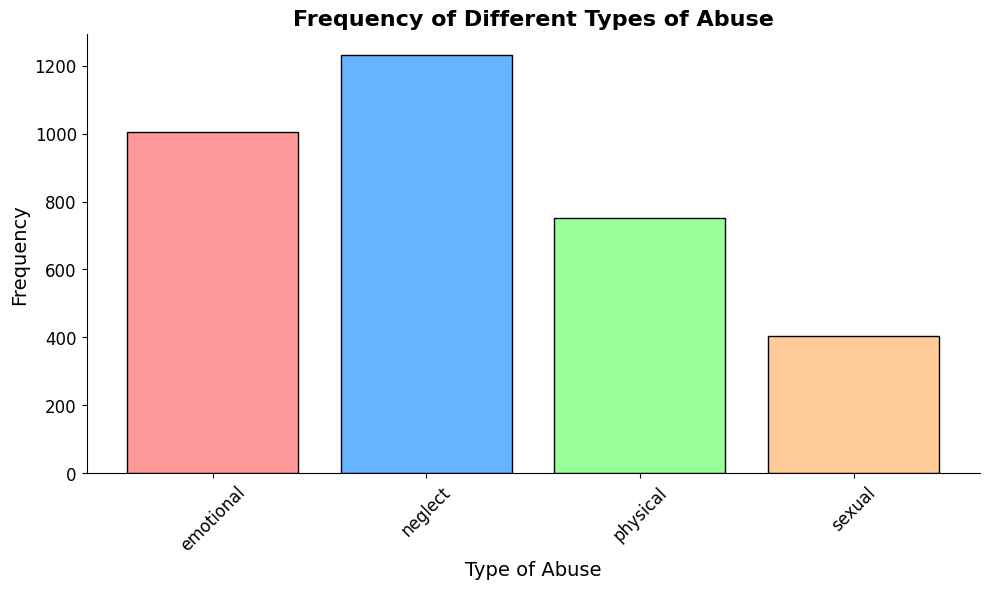Which type of abuse has the highest frequency? By observing the heights of the bars, which represent the frequencies, we can see that the bar for neglect is the tallest. Therefore, neglect has the highest frequency.
Answer: Neglect How much higher is the frequency of neglect compared to sexual abuse? First, note the frequencies: neglect is around 1,333 and sexual abuse is approximately 403. Subtract the frequency of sexual abuse from neglect (1,333 - 403) to find the difference.
Answer: 930 What is the average frequency of physical abuse? Add all the frequencies of physical abuse (90 + 85 + 95 + 80 + 100 + 105 + 110 + 88), which equals 753. Divide by the number of data points (8) to find the average.
Answer: 94.125 Which type of abuse has the lowest frequency? By looking at the heights of the bars, we can see that the bar for sexual abuse is the shortest. Therefore, sexual abuse has the lowest frequency.
Answer: Sexual abuse What is the combined frequency of emotional and physical abuse? Add the total frequencies for emotional abuse (1,105) and physical abuse (753). The combined frequency can be calculated as 1,105 + 753.
Answer: 1,858 Compare the average frequencies of emotional and physical abuse. Which one is higher? Calculate the average frequency of emotional abuse by adding all frequencies (1,105) and dividing by the number of data points (8), which equals 138.125. For physical abuse, the average is 94.125. Since 138.125 is greater than 94.125, emotional abuse has the higher average frequency.
Answer: Emotional abuse What is the difference in frequency between emotional and physical abuse? The total frequency of emotional abuse is 1,105, and the total frequency of physical abuse is 753. Subtract the frequency of physical abuse from emotional abuse (1,105 - 753).
Answer: 352 